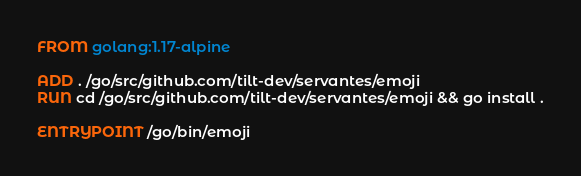Convert code to text. <code><loc_0><loc_0><loc_500><loc_500><_Dockerfile_>FROM golang:1.17-alpine

ADD . /go/src/github.com/tilt-dev/servantes/emoji
RUN cd /go/src/github.com/tilt-dev/servantes/emoji && go install .

ENTRYPOINT /go/bin/emoji
</code> 